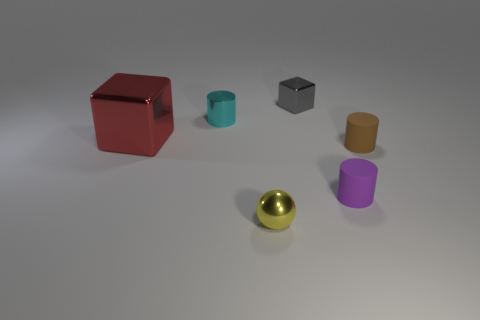Add 4 big red objects. How many objects exist? 10 Subtract all balls. How many objects are left? 5 Subtract all metallic cubes. Subtract all brown cylinders. How many objects are left? 3 Add 1 tiny yellow objects. How many tiny yellow objects are left? 2 Add 3 blue cubes. How many blue cubes exist? 3 Subtract 0 yellow cubes. How many objects are left? 6 